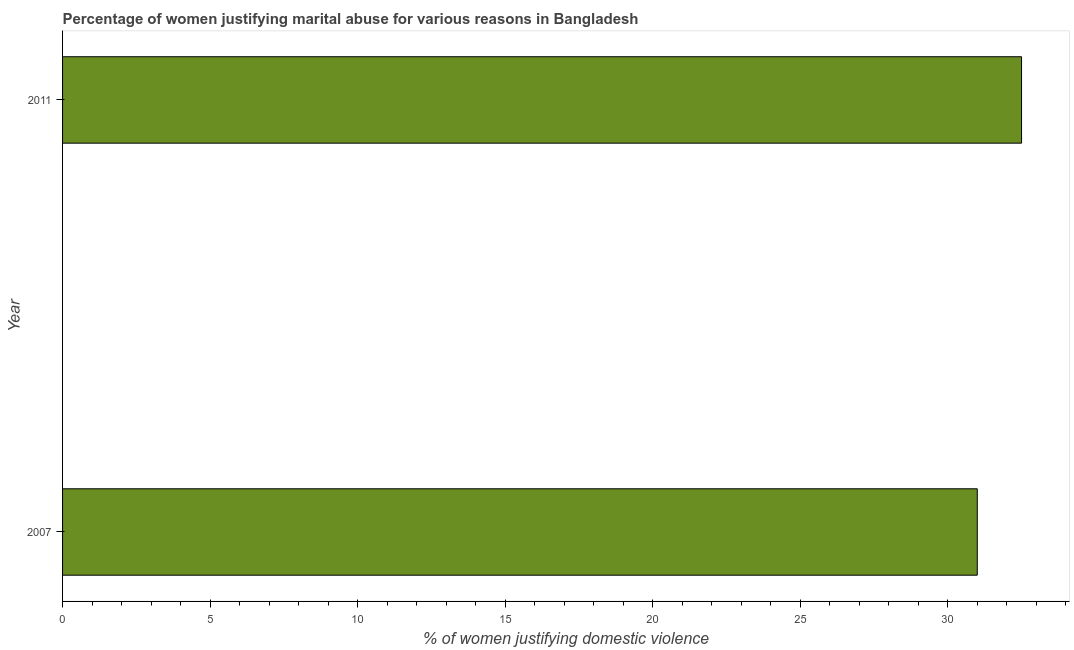What is the title of the graph?
Keep it short and to the point. Percentage of women justifying marital abuse for various reasons in Bangladesh. What is the label or title of the X-axis?
Your answer should be compact. % of women justifying domestic violence. What is the percentage of women justifying marital abuse in 2011?
Give a very brief answer. 32.5. Across all years, what is the maximum percentage of women justifying marital abuse?
Your answer should be compact. 32.5. In which year was the percentage of women justifying marital abuse minimum?
Offer a terse response. 2007. What is the sum of the percentage of women justifying marital abuse?
Offer a terse response. 63.5. What is the difference between the percentage of women justifying marital abuse in 2007 and 2011?
Provide a succinct answer. -1.5. What is the average percentage of women justifying marital abuse per year?
Keep it short and to the point. 31.75. What is the median percentage of women justifying marital abuse?
Ensure brevity in your answer.  31.75. What is the ratio of the percentage of women justifying marital abuse in 2007 to that in 2011?
Offer a terse response. 0.95. In how many years, is the percentage of women justifying marital abuse greater than the average percentage of women justifying marital abuse taken over all years?
Ensure brevity in your answer.  1. Are all the bars in the graph horizontal?
Offer a terse response. Yes. How many years are there in the graph?
Keep it short and to the point. 2. What is the difference between two consecutive major ticks on the X-axis?
Keep it short and to the point. 5. Are the values on the major ticks of X-axis written in scientific E-notation?
Your answer should be compact. No. What is the % of women justifying domestic violence of 2007?
Give a very brief answer. 31. What is the % of women justifying domestic violence in 2011?
Give a very brief answer. 32.5. What is the ratio of the % of women justifying domestic violence in 2007 to that in 2011?
Provide a short and direct response. 0.95. 